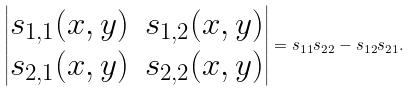Convert formula to latex. <formula><loc_0><loc_0><loc_500><loc_500>\left | \begin{matrix} s _ { 1 , 1 } ( x , y ) & s _ { 1 , 2 } ( x , y ) \\ s _ { 2 , 1 } ( x , y ) & s _ { 2 , 2 } ( x , y ) \end{matrix} \right | = s _ { 1 1 } s _ { 2 2 } - s _ { 1 2 } s _ { 2 1 } .</formula> 